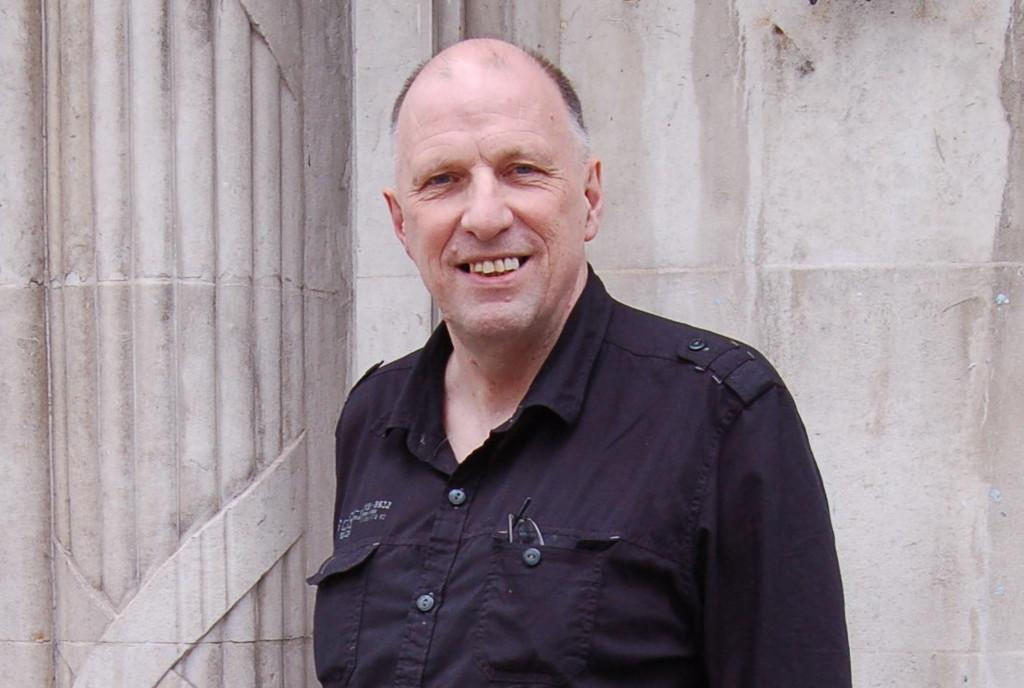What is the main subject of the image? There is a person in the image. What is the person wearing? The person is wearing a black dress. What is the person's facial expression? The person is smiling. What can be seen in the background of the image? There is a wall in the background of the image. What stage of development is the pan in the image? There is no pan present in the image. Can you describe the battle taking place in the image? There is no battle depicted in the image; it features a person wearing a black dress and smiling. 